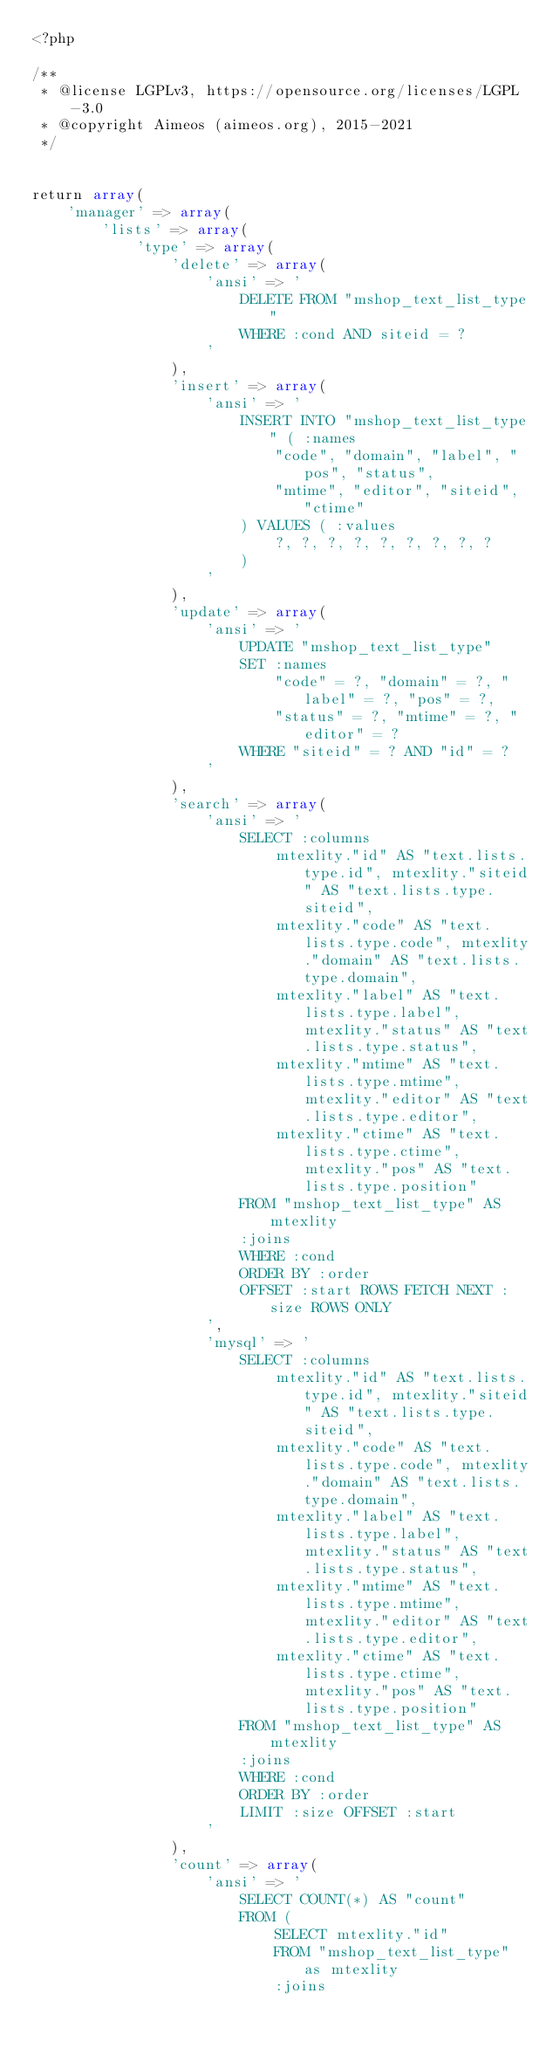Convert code to text. <code><loc_0><loc_0><loc_500><loc_500><_PHP_><?php

/**
 * @license LGPLv3, https://opensource.org/licenses/LGPL-3.0
 * @copyright Aimeos (aimeos.org), 2015-2021
 */


return array(
	'manager' => array(
		'lists' => array(
			'type' => array(
				'delete' => array(
					'ansi' => '
						DELETE FROM "mshop_text_list_type"
						WHERE :cond AND siteid = ?
					'
				),
				'insert' => array(
					'ansi' => '
						INSERT INTO "mshop_text_list_type" ( :names
							"code", "domain", "label", "pos", "status",
							"mtime", "editor", "siteid", "ctime"
						) VALUES ( :values
							?, ?, ?, ?, ?, ?, ?, ?, ?
						)
					'
				),
				'update' => array(
					'ansi' => '
						UPDATE "mshop_text_list_type"
						SET :names
							"code" = ?, "domain" = ?, "label" = ?, "pos" = ?,
							"status" = ?, "mtime" = ?, "editor" = ?
						WHERE "siteid" = ? AND "id" = ?
					'
				),
				'search' => array(
					'ansi' => '
						SELECT :columns
							mtexlity."id" AS "text.lists.type.id", mtexlity."siteid" AS "text.lists.type.siteid",
							mtexlity."code" AS "text.lists.type.code", mtexlity."domain" AS "text.lists.type.domain",
							mtexlity."label" AS "text.lists.type.label", mtexlity."status" AS "text.lists.type.status",
							mtexlity."mtime" AS "text.lists.type.mtime", mtexlity."editor" AS "text.lists.type.editor",
							mtexlity."ctime" AS "text.lists.type.ctime", mtexlity."pos" AS "text.lists.type.position"
						FROM "mshop_text_list_type" AS mtexlity
						:joins
						WHERE :cond
						ORDER BY :order
						OFFSET :start ROWS FETCH NEXT :size ROWS ONLY
					',
					'mysql' => '
						SELECT :columns
							mtexlity."id" AS "text.lists.type.id", mtexlity."siteid" AS "text.lists.type.siteid",
							mtexlity."code" AS "text.lists.type.code", mtexlity."domain" AS "text.lists.type.domain",
							mtexlity."label" AS "text.lists.type.label", mtexlity."status" AS "text.lists.type.status",
							mtexlity."mtime" AS "text.lists.type.mtime", mtexlity."editor" AS "text.lists.type.editor",
							mtexlity."ctime" AS "text.lists.type.ctime", mtexlity."pos" AS "text.lists.type.position"
						FROM "mshop_text_list_type" AS mtexlity
						:joins
						WHERE :cond
						ORDER BY :order
						LIMIT :size OFFSET :start
					'
				),
				'count' => array(
					'ansi' => '
						SELECT COUNT(*) AS "count"
						FROM (
							SELECT mtexlity."id"
							FROM "mshop_text_list_type" as mtexlity
							:joins</code> 